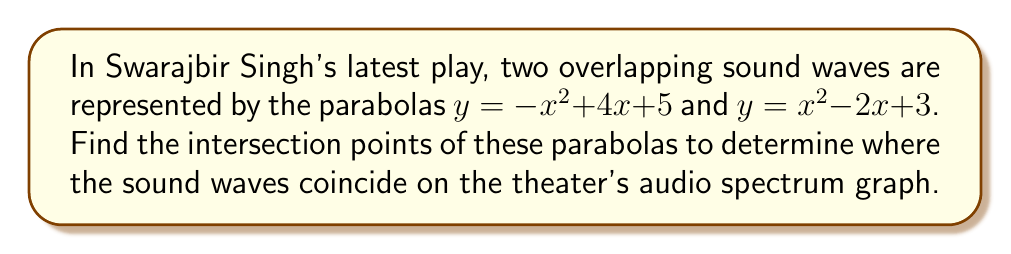Could you help me with this problem? To find the intersection points of the two parabolas, we need to solve the system of equations:

$$y = -x^2 + 4x + 5$$
$$y = x^2 - 2x + 3$$

1) Since these points intersect, we can set the equations equal to each other:

   $$-x^2 + 4x + 5 = x^2 - 2x + 3$$

2) Rearrange the equation to standard form:

   $$2x^2 - 6x - 2 = 0$$

3) This is a quadratic equation. We can solve it using the quadratic formula:
   
   $$x = \frac{-b \pm \sqrt{b^2 - 4ac}}{2a}$$

   Where $a = 2$, $b = -6$, and $c = -2$

4) Substituting these values:

   $$x = \frac{6 \pm \sqrt{36 - 4(2)(-2)}}{2(2)}$$
   $$x = \frac{6 \pm \sqrt{36 + 16}}{4}$$
   $$x = \frac{6 \pm \sqrt{52}}{4}$$
   $$x = \frac{6 \pm 2\sqrt{13}}{4}$$

5) Simplify:

   $$x = \frac{3 \pm \sqrt{13}}{2}$$

6) This gives us two x-coordinates:

   $$x_1 = \frac{3 + \sqrt{13}}{2} \approx 3.303$$
   $$x_2 = \frac{3 - \sqrt{13}}{2} \approx 0.697$$

7) To find the y-coordinates, we can substitute either x value into either of the original equations. Let's use the first equation:

   For $x_1$: $y = -((\frac{3 + \sqrt{13}}{2})^2) + 4(\frac{3 + \sqrt{13}}{2}) + 5 = \frac{23 + 3\sqrt{13}}{2} \approx 16.955$

   For $x_2$: $y = -((\frac{3 - \sqrt{13}}{2})^2) + 4(\frac{3 - \sqrt{13}}{2}) + 5 = \frac{23 - 3\sqrt{13}}{2} \approx 6.045$

Therefore, the intersection points are $(\frac{3 + \sqrt{13}}{2}, \frac{23 + 3\sqrt{13}}{2})$ and $(\frac{3 - \sqrt{13}}{2}, \frac{23 - 3\sqrt{13}}{2})$.
Answer: $(\frac{3 + \sqrt{13}}{2}, \frac{23 + 3\sqrt{13}}{2})$ and $(\frac{3 - \sqrt{13}}{2}, \frac{23 - 3\sqrt{13}}{2})$ 